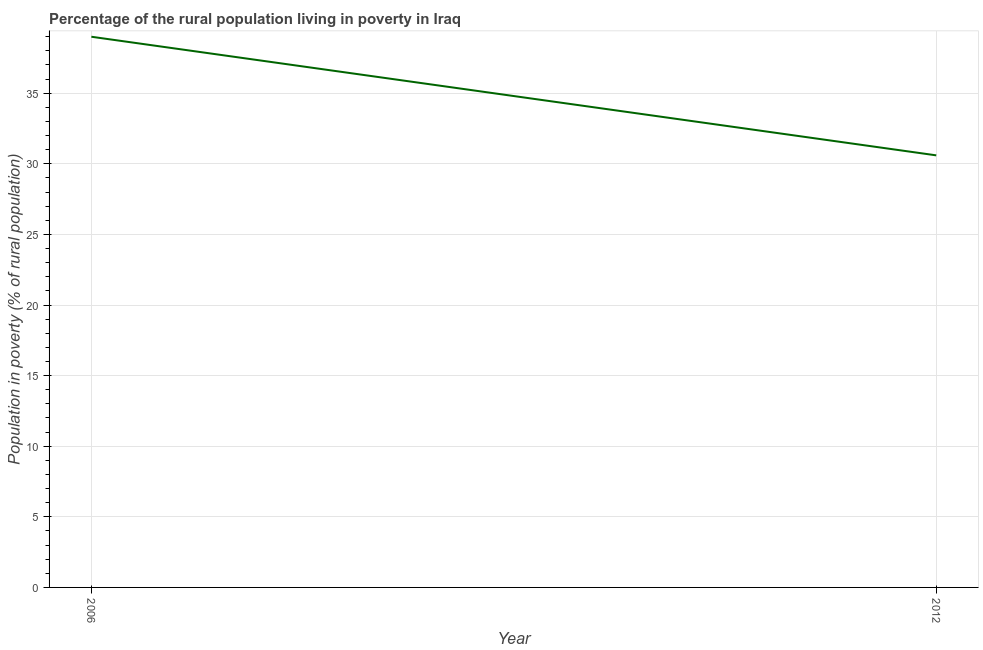What is the percentage of rural population living below poverty line in 2012?
Keep it short and to the point. 30.6. Across all years, what is the minimum percentage of rural population living below poverty line?
Make the answer very short. 30.6. What is the sum of the percentage of rural population living below poverty line?
Keep it short and to the point. 69.6. What is the difference between the percentage of rural population living below poverty line in 2006 and 2012?
Your answer should be very brief. 8.4. What is the average percentage of rural population living below poverty line per year?
Ensure brevity in your answer.  34.8. What is the median percentage of rural population living below poverty line?
Keep it short and to the point. 34.8. In how many years, is the percentage of rural population living below poverty line greater than 18 %?
Offer a very short reply. 2. Do a majority of the years between 2006 and 2012 (inclusive) have percentage of rural population living below poverty line greater than 25 %?
Your response must be concise. Yes. What is the ratio of the percentage of rural population living below poverty line in 2006 to that in 2012?
Your answer should be compact. 1.27. In how many years, is the percentage of rural population living below poverty line greater than the average percentage of rural population living below poverty line taken over all years?
Ensure brevity in your answer.  1. How many lines are there?
Offer a very short reply. 1. How many years are there in the graph?
Your answer should be very brief. 2. Are the values on the major ticks of Y-axis written in scientific E-notation?
Provide a short and direct response. No. Does the graph contain any zero values?
Your answer should be very brief. No. Does the graph contain grids?
Your answer should be very brief. Yes. What is the title of the graph?
Keep it short and to the point. Percentage of the rural population living in poverty in Iraq. What is the label or title of the X-axis?
Ensure brevity in your answer.  Year. What is the label or title of the Y-axis?
Provide a succinct answer. Population in poverty (% of rural population). What is the Population in poverty (% of rural population) of 2012?
Ensure brevity in your answer.  30.6. What is the ratio of the Population in poverty (% of rural population) in 2006 to that in 2012?
Give a very brief answer. 1.27. 